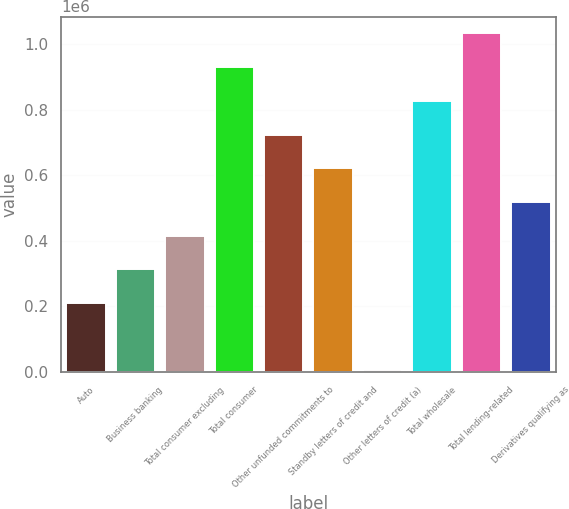<chart> <loc_0><loc_0><loc_500><loc_500><bar_chart><fcel>Auto<fcel>Business banking<fcel>Total consumer excluding<fcel>Total consumer<fcel>Other unfunded commitments to<fcel>Standby letters of credit and<fcel>Other letters of credit (a)<fcel>Total wholesale<fcel>Total lending-related<fcel>Derivatives qualifying as<nl><fcel>210350<fcel>313016<fcel>415681<fcel>929007<fcel>723676<fcel>621011<fcel>5020<fcel>826342<fcel>1.03167e+06<fcel>518346<nl></chart> 